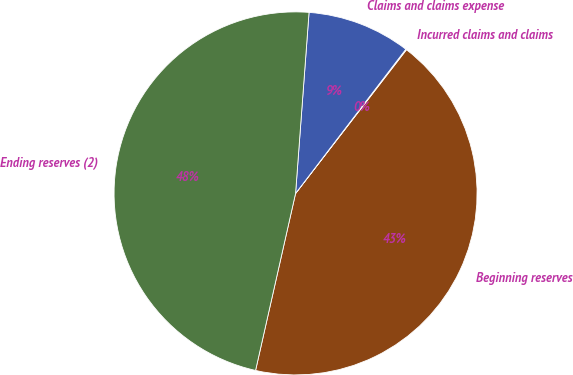Convert chart. <chart><loc_0><loc_0><loc_500><loc_500><pie_chart><fcel>Beginning reserves<fcel>Incurred claims and claims<fcel>Claims and claims expense<fcel>Ending reserves (2)<nl><fcel>43.08%<fcel>0.07%<fcel>9.21%<fcel>47.65%<nl></chart> 